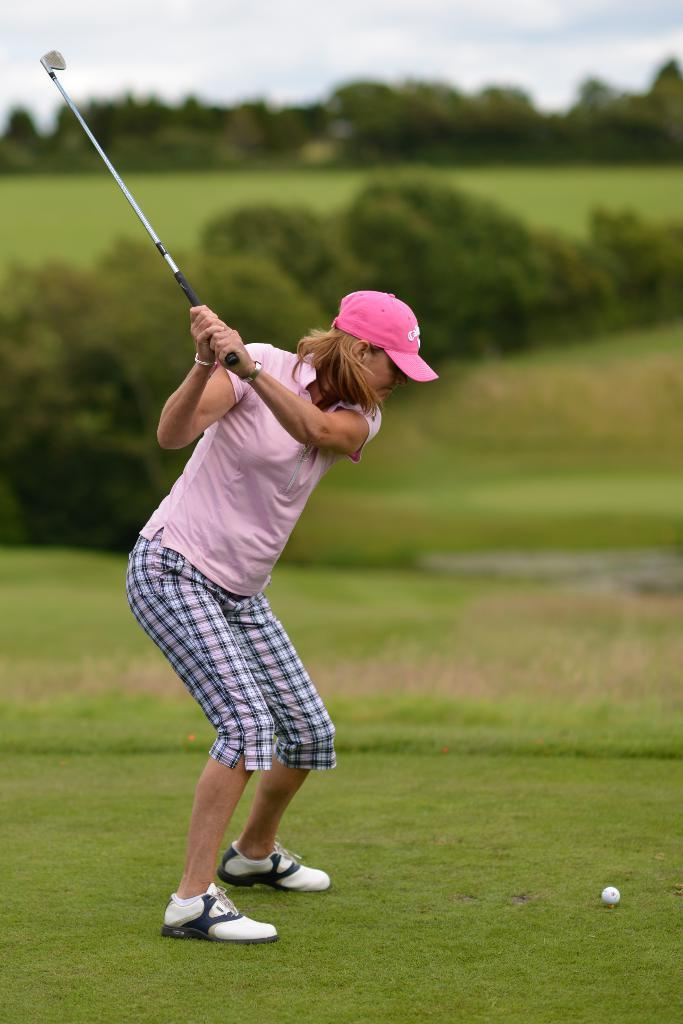Who is the main subject in the picture? There is a woman in the picture. What is the woman holding in the image? The woman is holding a hockey bat. What type of natural environment is visible in the picture? There are trees in the picture. How would you describe the weather based on the image? The sky is clear in the picture, suggesting good weather. How many islands can be seen in the picture? There are no islands visible in the picture. What type of curve is present in the woman's hockey bat? The woman's hockey bat is not visible in enough detail to determine the type of curve in the image. --- Facts: 1. There is a car in the image. 2. The car is red. 3. The car has four wheels. 4. There is a road in the image. 5. The road is paved. Absurd Topics: ocean, dance, mountain Conversation: What is the main subject in the image? There is a car in the image. What color is the car? The car is red. How many wheels does the car have? The car has four wheels. What type of surface is visible in the image? There is a road in the image, and it is paved. Reasoning: Let's think step by step in order to produce the conversation. We start by identifying the main subject in the image, which is the car. Then, we describe the car's color and the number of wheels it has. Next, we mention the type of surface visible in the image, which is a paved road. Absurd Question/Answer: Can you see any mountains in the background of the image? There are no mountains visible in the image. What type of dance is the car performing in the image? Cars do not perform dances; they are inanimate objects. 